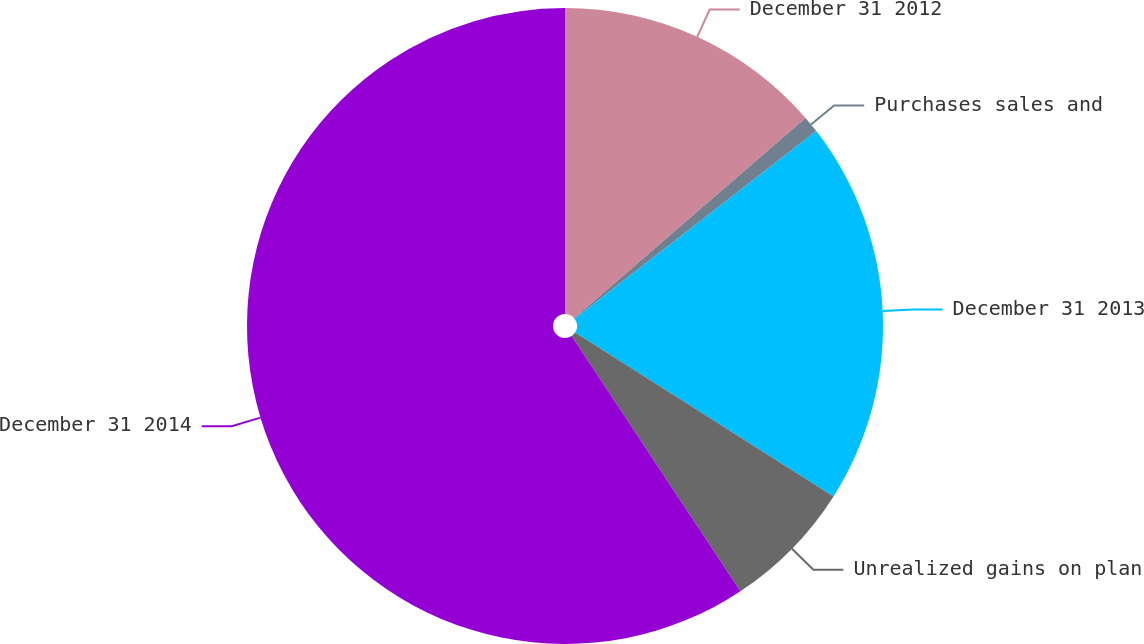<chart> <loc_0><loc_0><loc_500><loc_500><pie_chart><fcel>December 31 2012<fcel>Purchases sales and<fcel>December 31 2013<fcel>Unrealized gains on plan<fcel>December 31 2014<nl><fcel>13.65%<fcel>0.85%<fcel>19.5%<fcel>6.7%<fcel>59.3%<nl></chart> 